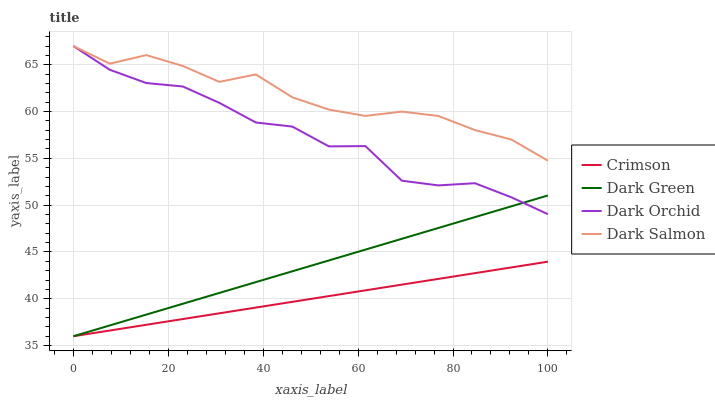Does Crimson have the minimum area under the curve?
Answer yes or no. Yes. Does Dark Salmon have the maximum area under the curve?
Answer yes or no. Yes. Does Dark Orchid have the minimum area under the curve?
Answer yes or no. No. Does Dark Orchid have the maximum area under the curve?
Answer yes or no. No. Is Crimson the smoothest?
Answer yes or no. Yes. Is Dark Orchid the roughest?
Answer yes or no. Yes. Is Dark Salmon the smoothest?
Answer yes or no. No. Is Dark Salmon the roughest?
Answer yes or no. No. Does Crimson have the lowest value?
Answer yes or no. Yes. Does Dark Orchid have the lowest value?
Answer yes or no. No. Does Dark Orchid have the highest value?
Answer yes or no. Yes. Does Dark Green have the highest value?
Answer yes or no. No. Is Crimson less than Dark Orchid?
Answer yes or no. Yes. Is Dark Salmon greater than Crimson?
Answer yes or no. Yes. Does Dark Orchid intersect Dark Green?
Answer yes or no. Yes. Is Dark Orchid less than Dark Green?
Answer yes or no. No. Is Dark Orchid greater than Dark Green?
Answer yes or no. No. Does Crimson intersect Dark Orchid?
Answer yes or no. No. 